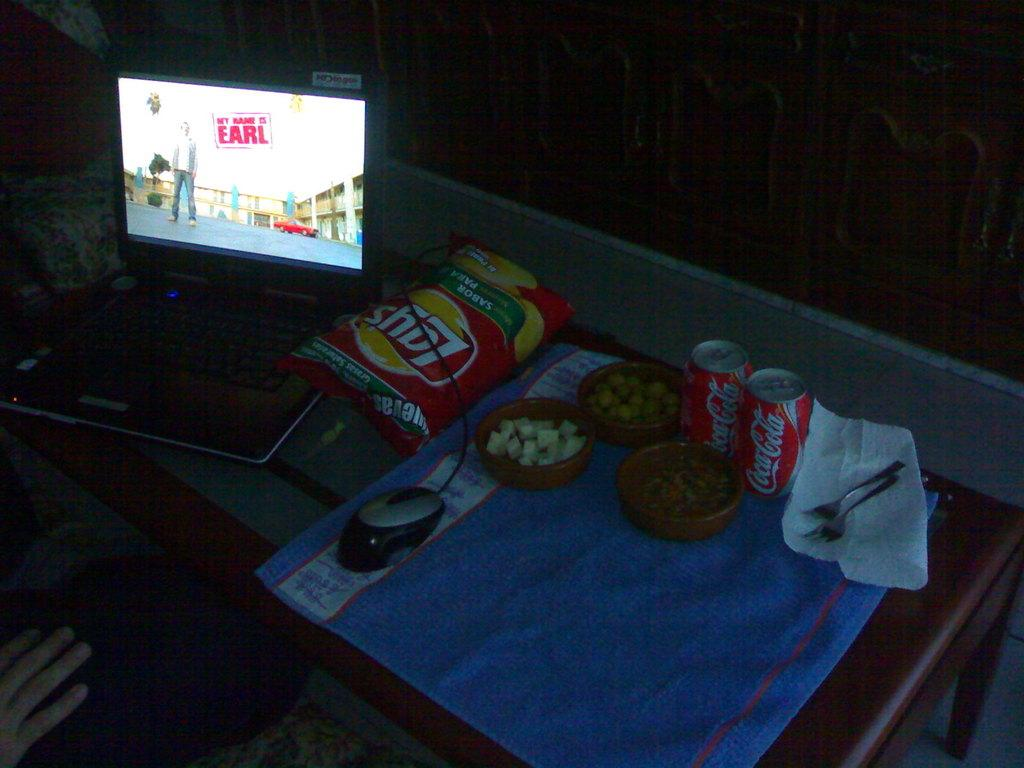Provide a one-sentence caption for the provided image. A bag of Lay's chips and two cans of Coca-Cola are on a table. 